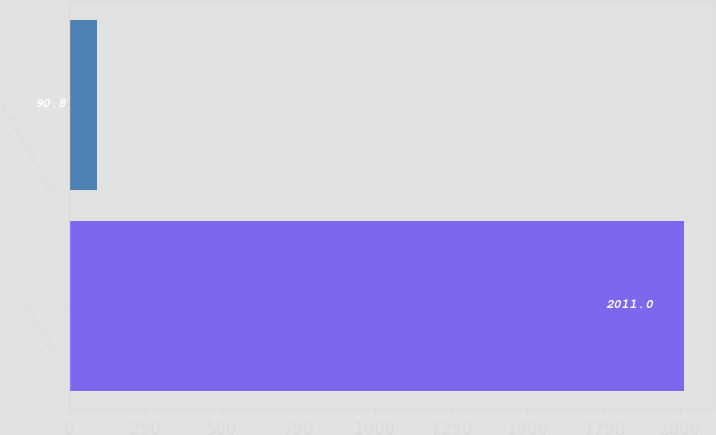Convert chart to OTSL. <chart><loc_0><loc_0><loc_500><loc_500><bar_chart><fcel>Accident Year<fcel>as of December 31 2013<nl><fcel>2011<fcel>90.8<nl></chart> 